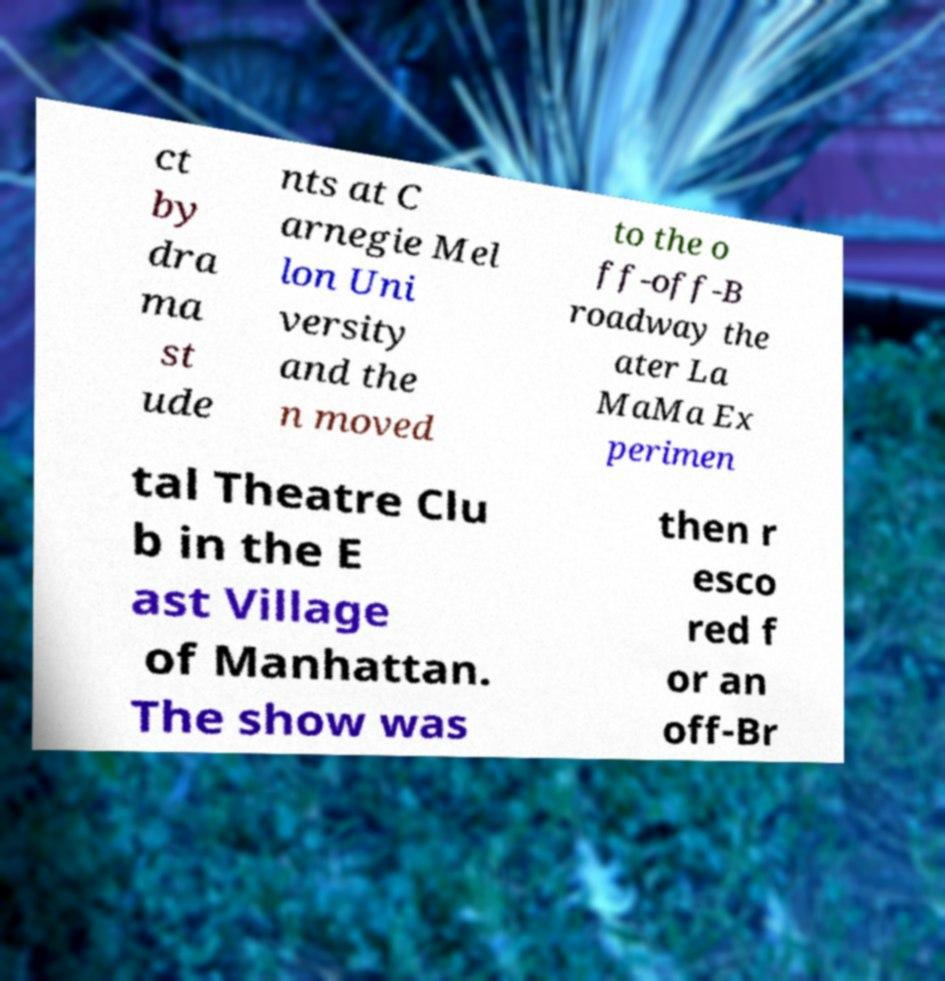I need the written content from this picture converted into text. Can you do that? ct by dra ma st ude nts at C arnegie Mel lon Uni versity and the n moved to the o ff-off-B roadway the ater La MaMa Ex perimen tal Theatre Clu b in the E ast Village of Manhattan. The show was then r esco red f or an off-Br 